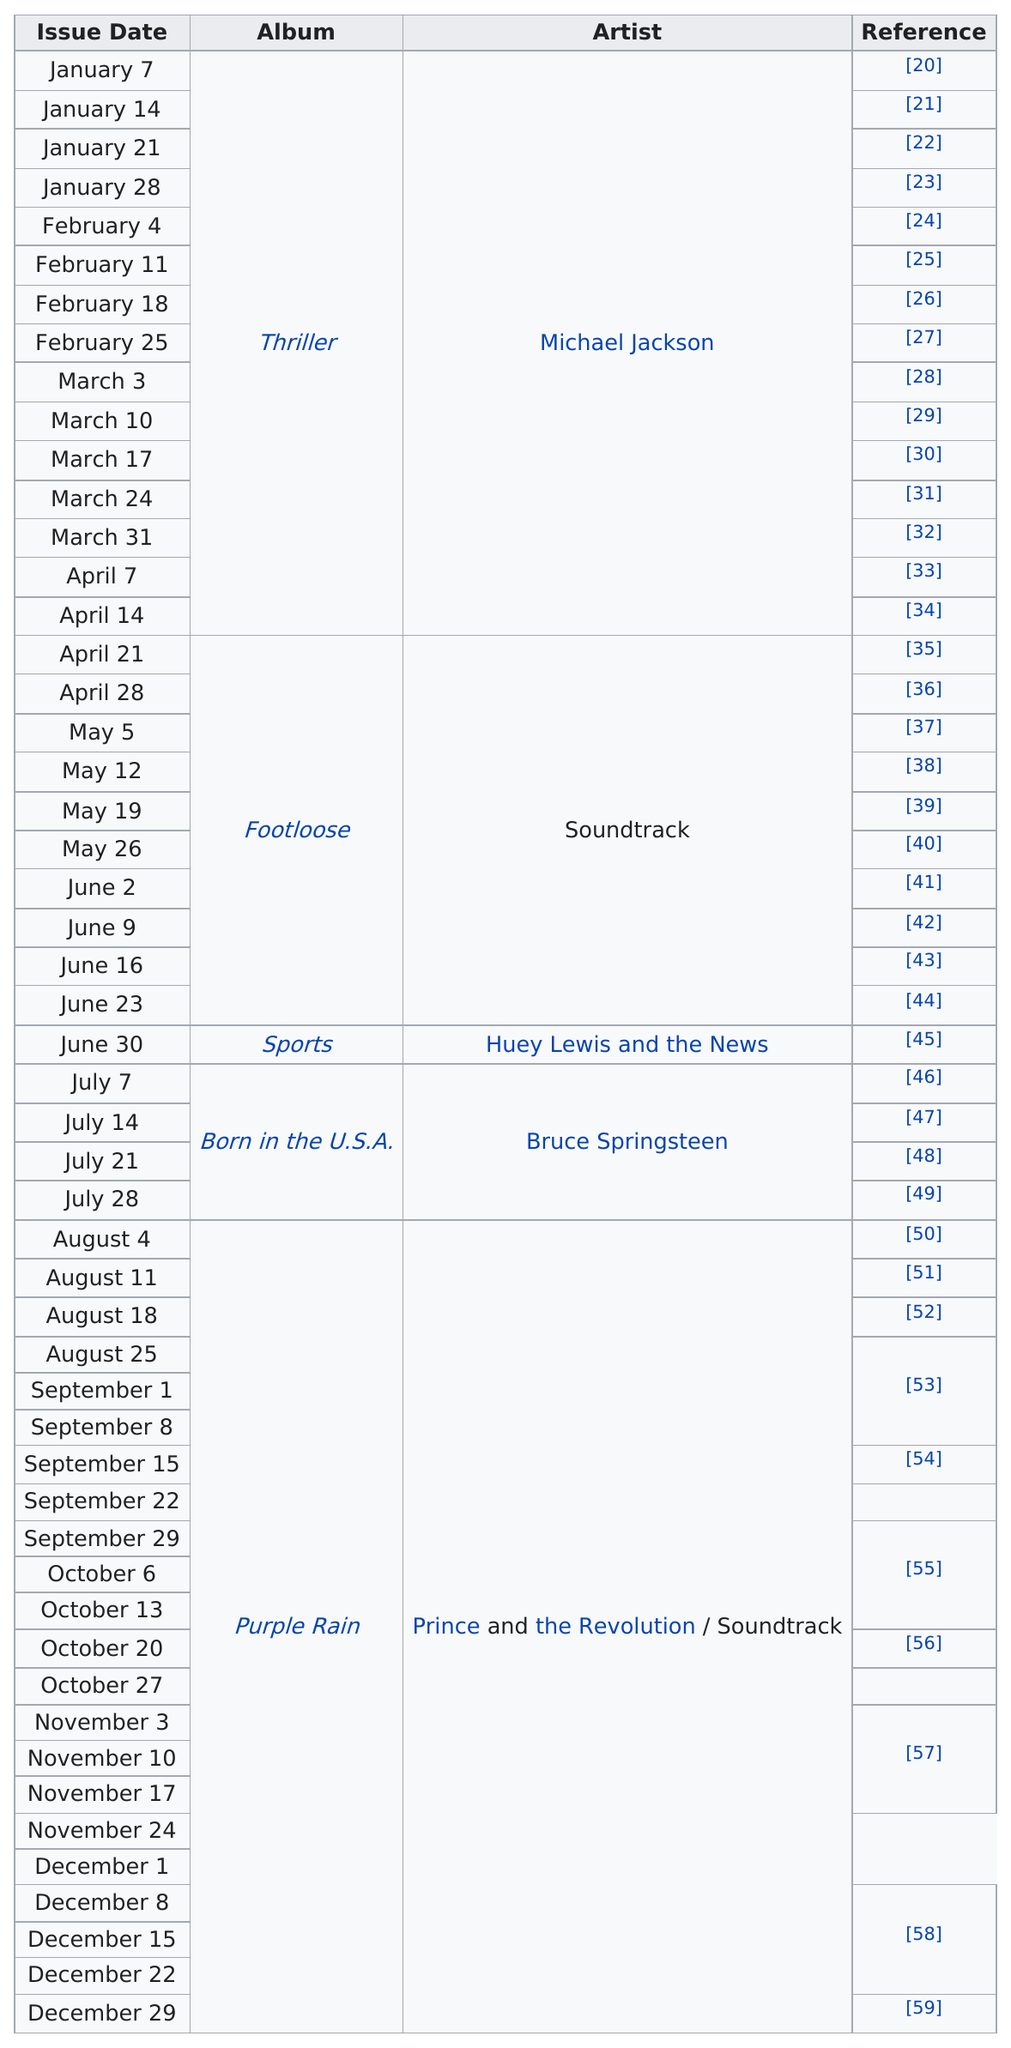Outline some significant characteristics in this image. For a period of 15 weeks, Michael Jackson held the top spot on the charts. 